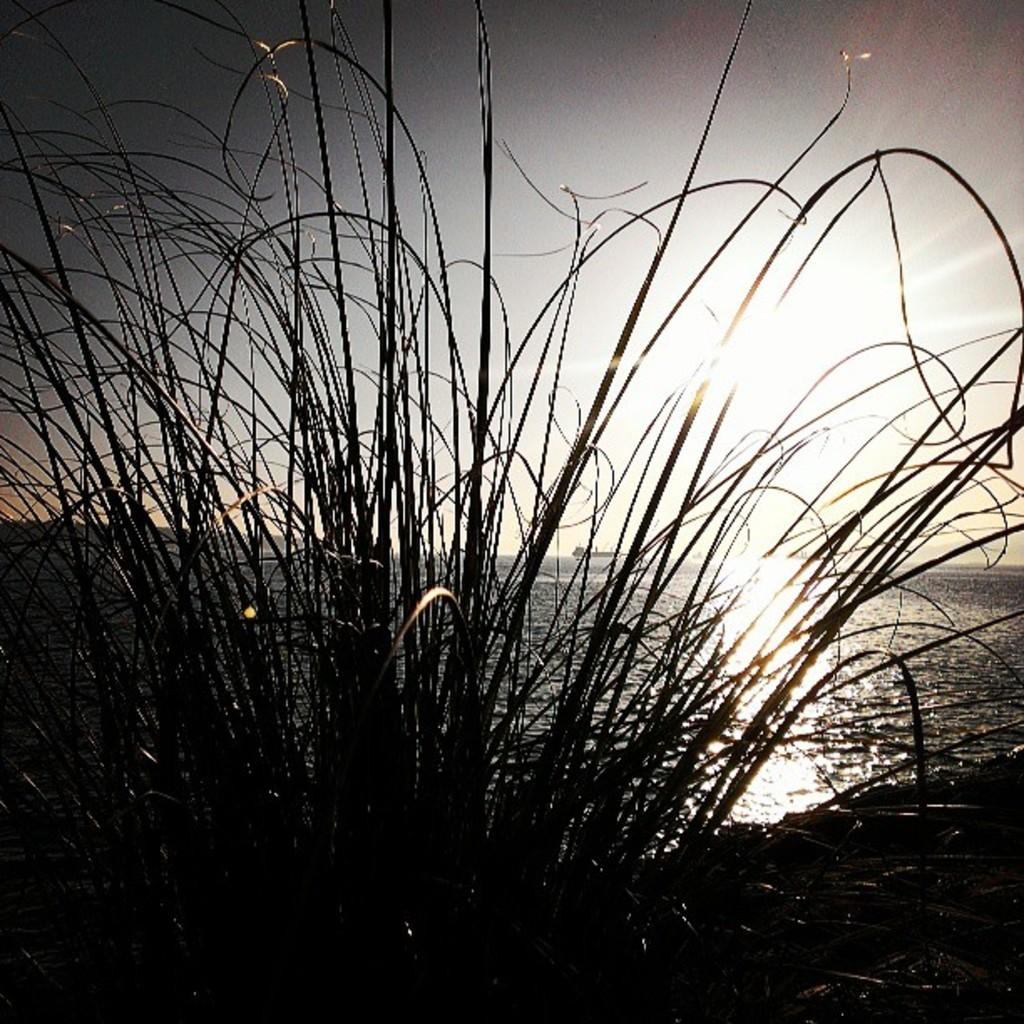What is located in the foreground of the image? There is a plant in the foreground of the image. What can be seen in the background of the image? There is a sea visible in the background of the image. What is visible at the top of the image? The sky is visible at the top of the image. What type of flower is being taught in the class in the image? There is no class or flower present in the image. How does the plant stretch towards the sky in the image? The plant does not stretch towards the sky in the image; it is stationary in the foreground. 